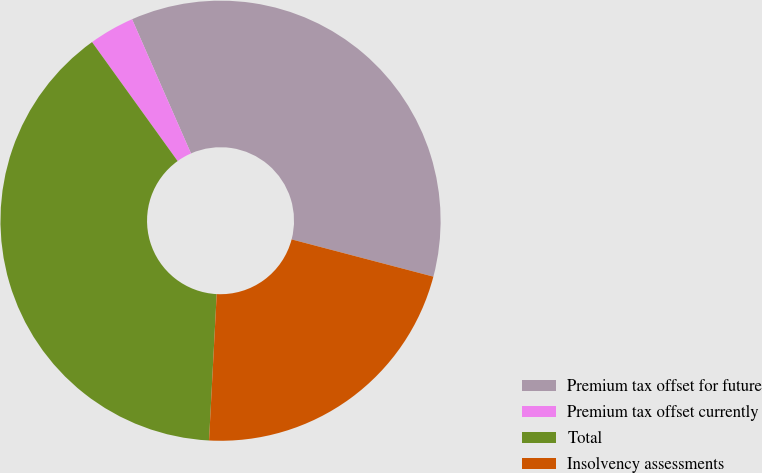<chart> <loc_0><loc_0><loc_500><loc_500><pie_chart><fcel>Premium tax offset for future<fcel>Premium tax offset currently<fcel>Total<fcel>Insolvency assessments<nl><fcel>35.67%<fcel>3.34%<fcel>39.24%<fcel>21.74%<nl></chart> 